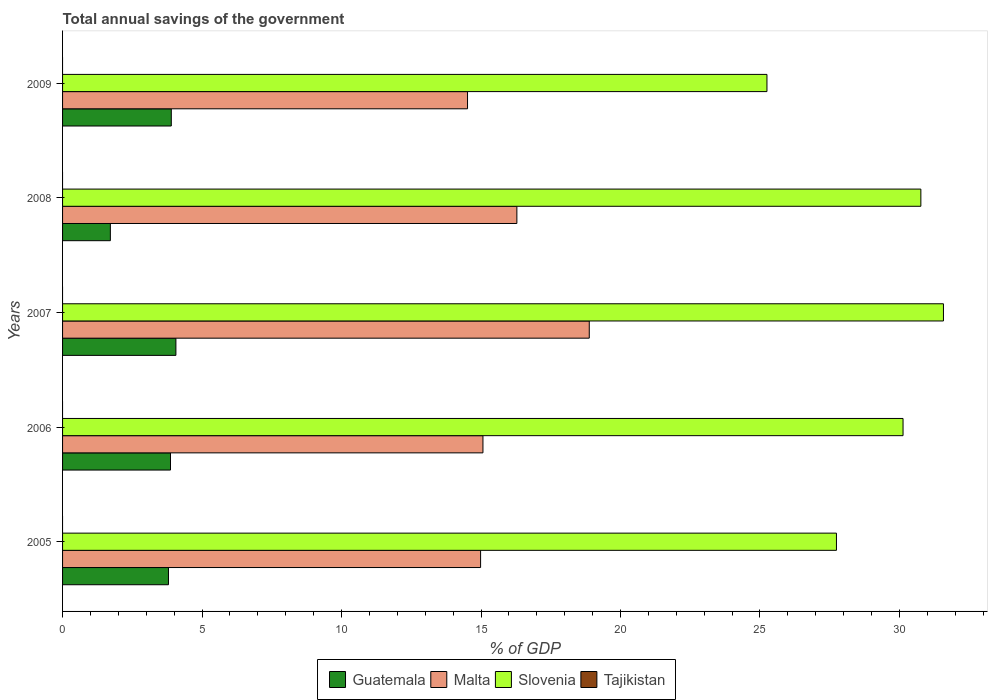How many groups of bars are there?
Give a very brief answer. 5. Are the number of bars on each tick of the Y-axis equal?
Ensure brevity in your answer.  Yes. In how many cases, is the number of bars for a given year not equal to the number of legend labels?
Make the answer very short. 5. Across all years, what is the maximum total annual savings of the government in Malta?
Your response must be concise. 18.88. Across all years, what is the minimum total annual savings of the government in Slovenia?
Make the answer very short. 25.25. What is the total total annual savings of the government in Guatemala in the graph?
Make the answer very short. 17.34. What is the difference between the total annual savings of the government in Guatemala in 2006 and that in 2008?
Give a very brief answer. 2.16. What is the difference between the total annual savings of the government in Malta in 2006 and the total annual savings of the government in Tajikistan in 2008?
Offer a very short reply. 15.07. What is the average total annual savings of the government in Guatemala per year?
Your answer should be very brief. 3.47. In the year 2007, what is the difference between the total annual savings of the government in Malta and total annual savings of the government in Guatemala?
Provide a succinct answer. 14.82. What is the ratio of the total annual savings of the government in Slovenia in 2007 to that in 2009?
Your answer should be compact. 1.25. Is the total annual savings of the government in Slovenia in 2007 less than that in 2008?
Ensure brevity in your answer.  No. Is the difference between the total annual savings of the government in Malta in 2008 and 2009 greater than the difference between the total annual savings of the government in Guatemala in 2008 and 2009?
Offer a terse response. Yes. What is the difference between the highest and the second highest total annual savings of the government in Malta?
Offer a terse response. 2.59. What is the difference between the highest and the lowest total annual savings of the government in Guatemala?
Give a very brief answer. 2.35. Is the sum of the total annual savings of the government in Malta in 2005 and 2006 greater than the maximum total annual savings of the government in Guatemala across all years?
Your answer should be very brief. Yes. Is it the case that in every year, the sum of the total annual savings of the government in Tajikistan and total annual savings of the government in Guatemala is greater than the sum of total annual savings of the government in Malta and total annual savings of the government in Slovenia?
Your answer should be compact. No. Are all the bars in the graph horizontal?
Your answer should be compact. Yes. What is the difference between two consecutive major ticks on the X-axis?
Your answer should be very brief. 5. What is the title of the graph?
Your answer should be compact. Total annual savings of the government. Does "Greece" appear as one of the legend labels in the graph?
Keep it short and to the point. No. What is the label or title of the X-axis?
Offer a terse response. % of GDP. What is the % of GDP of Guatemala in 2005?
Your answer should be compact. 3.8. What is the % of GDP of Malta in 2005?
Your answer should be very brief. 14.99. What is the % of GDP in Slovenia in 2005?
Provide a short and direct response. 27.74. What is the % of GDP in Tajikistan in 2005?
Your response must be concise. 0. What is the % of GDP of Guatemala in 2006?
Keep it short and to the point. 3.87. What is the % of GDP of Malta in 2006?
Your answer should be compact. 15.07. What is the % of GDP in Slovenia in 2006?
Provide a succinct answer. 30.13. What is the % of GDP of Tajikistan in 2006?
Your answer should be compact. 0. What is the % of GDP in Guatemala in 2007?
Provide a succinct answer. 4.06. What is the % of GDP in Malta in 2007?
Keep it short and to the point. 18.88. What is the % of GDP in Slovenia in 2007?
Your answer should be compact. 31.58. What is the % of GDP in Guatemala in 2008?
Your answer should be very brief. 1.71. What is the % of GDP in Malta in 2008?
Offer a very short reply. 16.29. What is the % of GDP in Slovenia in 2008?
Your answer should be very brief. 30.77. What is the % of GDP of Guatemala in 2009?
Make the answer very short. 3.9. What is the % of GDP of Malta in 2009?
Provide a short and direct response. 14.52. What is the % of GDP in Slovenia in 2009?
Make the answer very short. 25.25. What is the % of GDP in Tajikistan in 2009?
Your response must be concise. 0. Across all years, what is the maximum % of GDP in Guatemala?
Ensure brevity in your answer.  4.06. Across all years, what is the maximum % of GDP in Malta?
Offer a terse response. 18.88. Across all years, what is the maximum % of GDP in Slovenia?
Your answer should be compact. 31.58. Across all years, what is the minimum % of GDP of Guatemala?
Offer a very short reply. 1.71. Across all years, what is the minimum % of GDP of Malta?
Your response must be concise. 14.52. Across all years, what is the minimum % of GDP of Slovenia?
Provide a succinct answer. 25.25. What is the total % of GDP in Guatemala in the graph?
Your response must be concise. 17.34. What is the total % of GDP of Malta in the graph?
Your response must be concise. 79.74. What is the total % of GDP in Slovenia in the graph?
Offer a very short reply. 145.47. What is the difference between the % of GDP of Guatemala in 2005 and that in 2006?
Your answer should be compact. -0.07. What is the difference between the % of GDP of Malta in 2005 and that in 2006?
Keep it short and to the point. -0.08. What is the difference between the % of GDP in Slovenia in 2005 and that in 2006?
Keep it short and to the point. -2.39. What is the difference between the % of GDP of Guatemala in 2005 and that in 2007?
Your answer should be compact. -0.27. What is the difference between the % of GDP in Malta in 2005 and that in 2007?
Your answer should be compact. -3.9. What is the difference between the % of GDP of Slovenia in 2005 and that in 2007?
Provide a succinct answer. -3.84. What is the difference between the % of GDP of Guatemala in 2005 and that in 2008?
Your answer should be compact. 2.08. What is the difference between the % of GDP in Malta in 2005 and that in 2008?
Provide a succinct answer. -1.3. What is the difference between the % of GDP in Slovenia in 2005 and that in 2008?
Provide a succinct answer. -3.03. What is the difference between the % of GDP in Guatemala in 2005 and that in 2009?
Provide a short and direct response. -0.1. What is the difference between the % of GDP in Malta in 2005 and that in 2009?
Your response must be concise. 0.47. What is the difference between the % of GDP of Slovenia in 2005 and that in 2009?
Ensure brevity in your answer.  2.49. What is the difference between the % of GDP of Guatemala in 2006 and that in 2007?
Your response must be concise. -0.19. What is the difference between the % of GDP in Malta in 2006 and that in 2007?
Give a very brief answer. -3.81. What is the difference between the % of GDP in Slovenia in 2006 and that in 2007?
Make the answer very short. -1.45. What is the difference between the % of GDP of Guatemala in 2006 and that in 2008?
Your answer should be very brief. 2.16. What is the difference between the % of GDP in Malta in 2006 and that in 2008?
Make the answer very short. -1.22. What is the difference between the % of GDP in Slovenia in 2006 and that in 2008?
Your answer should be very brief. -0.64. What is the difference between the % of GDP in Guatemala in 2006 and that in 2009?
Your answer should be very brief. -0.03. What is the difference between the % of GDP of Malta in 2006 and that in 2009?
Provide a short and direct response. 0.55. What is the difference between the % of GDP in Slovenia in 2006 and that in 2009?
Keep it short and to the point. 4.88. What is the difference between the % of GDP of Guatemala in 2007 and that in 2008?
Give a very brief answer. 2.35. What is the difference between the % of GDP in Malta in 2007 and that in 2008?
Offer a very short reply. 2.59. What is the difference between the % of GDP of Slovenia in 2007 and that in 2008?
Ensure brevity in your answer.  0.81. What is the difference between the % of GDP in Guatemala in 2007 and that in 2009?
Your answer should be very brief. 0.17. What is the difference between the % of GDP in Malta in 2007 and that in 2009?
Offer a very short reply. 4.36. What is the difference between the % of GDP in Slovenia in 2007 and that in 2009?
Ensure brevity in your answer.  6.33. What is the difference between the % of GDP in Guatemala in 2008 and that in 2009?
Make the answer very short. -2.18. What is the difference between the % of GDP in Malta in 2008 and that in 2009?
Keep it short and to the point. 1.77. What is the difference between the % of GDP of Slovenia in 2008 and that in 2009?
Provide a succinct answer. 5.52. What is the difference between the % of GDP in Guatemala in 2005 and the % of GDP in Malta in 2006?
Make the answer very short. -11.27. What is the difference between the % of GDP in Guatemala in 2005 and the % of GDP in Slovenia in 2006?
Offer a very short reply. -26.33. What is the difference between the % of GDP in Malta in 2005 and the % of GDP in Slovenia in 2006?
Your answer should be compact. -15.14. What is the difference between the % of GDP in Guatemala in 2005 and the % of GDP in Malta in 2007?
Give a very brief answer. -15.08. What is the difference between the % of GDP in Guatemala in 2005 and the % of GDP in Slovenia in 2007?
Make the answer very short. -27.78. What is the difference between the % of GDP of Malta in 2005 and the % of GDP of Slovenia in 2007?
Provide a succinct answer. -16.59. What is the difference between the % of GDP of Guatemala in 2005 and the % of GDP of Malta in 2008?
Your answer should be compact. -12.49. What is the difference between the % of GDP in Guatemala in 2005 and the % of GDP in Slovenia in 2008?
Give a very brief answer. -26.97. What is the difference between the % of GDP of Malta in 2005 and the % of GDP of Slovenia in 2008?
Keep it short and to the point. -15.78. What is the difference between the % of GDP in Guatemala in 2005 and the % of GDP in Malta in 2009?
Keep it short and to the point. -10.72. What is the difference between the % of GDP in Guatemala in 2005 and the % of GDP in Slovenia in 2009?
Your answer should be very brief. -21.45. What is the difference between the % of GDP in Malta in 2005 and the % of GDP in Slovenia in 2009?
Keep it short and to the point. -10.27. What is the difference between the % of GDP in Guatemala in 2006 and the % of GDP in Malta in 2007?
Offer a terse response. -15.01. What is the difference between the % of GDP in Guatemala in 2006 and the % of GDP in Slovenia in 2007?
Your answer should be very brief. -27.71. What is the difference between the % of GDP of Malta in 2006 and the % of GDP of Slovenia in 2007?
Provide a short and direct response. -16.51. What is the difference between the % of GDP of Guatemala in 2006 and the % of GDP of Malta in 2008?
Your answer should be very brief. -12.42. What is the difference between the % of GDP of Guatemala in 2006 and the % of GDP of Slovenia in 2008?
Your answer should be very brief. -26.9. What is the difference between the % of GDP in Malta in 2006 and the % of GDP in Slovenia in 2008?
Ensure brevity in your answer.  -15.7. What is the difference between the % of GDP of Guatemala in 2006 and the % of GDP of Malta in 2009?
Make the answer very short. -10.65. What is the difference between the % of GDP in Guatemala in 2006 and the % of GDP in Slovenia in 2009?
Provide a short and direct response. -21.38. What is the difference between the % of GDP of Malta in 2006 and the % of GDP of Slovenia in 2009?
Your answer should be very brief. -10.18. What is the difference between the % of GDP of Guatemala in 2007 and the % of GDP of Malta in 2008?
Keep it short and to the point. -12.22. What is the difference between the % of GDP of Guatemala in 2007 and the % of GDP of Slovenia in 2008?
Provide a succinct answer. -26.7. What is the difference between the % of GDP in Malta in 2007 and the % of GDP in Slovenia in 2008?
Give a very brief answer. -11.89. What is the difference between the % of GDP of Guatemala in 2007 and the % of GDP of Malta in 2009?
Your answer should be compact. -10.45. What is the difference between the % of GDP of Guatemala in 2007 and the % of GDP of Slovenia in 2009?
Offer a terse response. -21.19. What is the difference between the % of GDP in Malta in 2007 and the % of GDP in Slovenia in 2009?
Keep it short and to the point. -6.37. What is the difference between the % of GDP in Guatemala in 2008 and the % of GDP in Malta in 2009?
Offer a very short reply. -12.8. What is the difference between the % of GDP of Guatemala in 2008 and the % of GDP of Slovenia in 2009?
Provide a short and direct response. -23.54. What is the difference between the % of GDP of Malta in 2008 and the % of GDP of Slovenia in 2009?
Ensure brevity in your answer.  -8.96. What is the average % of GDP in Guatemala per year?
Offer a very short reply. 3.47. What is the average % of GDP in Malta per year?
Your answer should be compact. 15.95. What is the average % of GDP in Slovenia per year?
Offer a terse response. 29.09. What is the average % of GDP in Tajikistan per year?
Your response must be concise. 0. In the year 2005, what is the difference between the % of GDP in Guatemala and % of GDP in Malta?
Offer a very short reply. -11.19. In the year 2005, what is the difference between the % of GDP of Guatemala and % of GDP of Slovenia?
Ensure brevity in your answer.  -23.95. In the year 2005, what is the difference between the % of GDP of Malta and % of GDP of Slovenia?
Your answer should be compact. -12.76. In the year 2006, what is the difference between the % of GDP in Guatemala and % of GDP in Malta?
Your response must be concise. -11.2. In the year 2006, what is the difference between the % of GDP of Guatemala and % of GDP of Slovenia?
Your response must be concise. -26.26. In the year 2006, what is the difference between the % of GDP of Malta and % of GDP of Slovenia?
Your answer should be compact. -15.06. In the year 2007, what is the difference between the % of GDP of Guatemala and % of GDP of Malta?
Provide a short and direct response. -14.82. In the year 2007, what is the difference between the % of GDP in Guatemala and % of GDP in Slovenia?
Provide a succinct answer. -27.52. In the year 2007, what is the difference between the % of GDP in Malta and % of GDP in Slovenia?
Offer a terse response. -12.7. In the year 2008, what is the difference between the % of GDP of Guatemala and % of GDP of Malta?
Your response must be concise. -14.57. In the year 2008, what is the difference between the % of GDP of Guatemala and % of GDP of Slovenia?
Your response must be concise. -29.05. In the year 2008, what is the difference between the % of GDP of Malta and % of GDP of Slovenia?
Provide a succinct answer. -14.48. In the year 2009, what is the difference between the % of GDP in Guatemala and % of GDP in Malta?
Offer a very short reply. -10.62. In the year 2009, what is the difference between the % of GDP of Guatemala and % of GDP of Slovenia?
Your answer should be compact. -21.35. In the year 2009, what is the difference between the % of GDP in Malta and % of GDP in Slovenia?
Provide a succinct answer. -10.73. What is the ratio of the % of GDP of Guatemala in 2005 to that in 2006?
Provide a short and direct response. 0.98. What is the ratio of the % of GDP of Malta in 2005 to that in 2006?
Provide a succinct answer. 0.99. What is the ratio of the % of GDP in Slovenia in 2005 to that in 2006?
Your answer should be very brief. 0.92. What is the ratio of the % of GDP of Guatemala in 2005 to that in 2007?
Offer a very short reply. 0.93. What is the ratio of the % of GDP of Malta in 2005 to that in 2007?
Give a very brief answer. 0.79. What is the ratio of the % of GDP in Slovenia in 2005 to that in 2007?
Your response must be concise. 0.88. What is the ratio of the % of GDP of Guatemala in 2005 to that in 2008?
Your answer should be compact. 2.22. What is the ratio of the % of GDP in Malta in 2005 to that in 2008?
Offer a very short reply. 0.92. What is the ratio of the % of GDP in Slovenia in 2005 to that in 2008?
Your answer should be very brief. 0.9. What is the ratio of the % of GDP in Malta in 2005 to that in 2009?
Your answer should be very brief. 1.03. What is the ratio of the % of GDP in Slovenia in 2005 to that in 2009?
Ensure brevity in your answer.  1.1. What is the ratio of the % of GDP of Guatemala in 2006 to that in 2007?
Give a very brief answer. 0.95. What is the ratio of the % of GDP in Malta in 2006 to that in 2007?
Offer a very short reply. 0.8. What is the ratio of the % of GDP of Slovenia in 2006 to that in 2007?
Give a very brief answer. 0.95. What is the ratio of the % of GDP of Guatemala in 2006 to that in 2008?
Make the answer very short. 2.26. What is the ratio of the % of GDP of Malta in 2006 to that in 2008?
Your response must be concise. 0.93. What is the ratio of the % of GDP of Slovenia in 2006 to that in 2008?
Make the answer very short. 0.98. What is the ratio of the % of GDP of Malta in 2006 to that in 2009?
Give a very brief answer. 1.04. What is the ratio of the % of GDP in Slovenia in 2006 to that in 2009?
Ensure brevity in your answer.  1.19. What is the ratio of the % of GDP of Guatemala in 2007 to that in 2008?
Ensure brevity in your answer.  2.37. What is the ratio of the % of GDP of Malta in 2007 to that in 2008?
Keep it short and to the point. 1.16. What is the ratio of the % of GDP of Slovenia in 2007 to that in 2008?
Ensure brevity in your answer.  1.03. What is the ratio of the % of GDP of Guatemala in 2007 to that in 2009?
Make the answer very short. 1.04. What is the ratio of the % of GDP of Malta in 2007 to that in 2009?
Your response must be concise. 1.3. What is the ratio of the % of GDP in Slovenia in 2007 to that in 2009?
Offer a terse response. 1.25. What is the ratio of the % of GDP in Guatemala in 2008 to that in 2009?
Keep it short and to the point. 0.44. What is the ratio of the % of GDP of Malta in 2008 to that in 2009?
Give a very brief answer. 1.12. What is the ratio of the % of GDP of Slovenia in 2008 to that in 2009?
Offer a terse response. 1.22. What is the difference between the highest and the second highest % of GDP of Guatemala?
Your answer should be compact. 0.17. What is the difference between the highest and the second highest % of GDP of Malta?
Offer a very short reply. 2.59. What is the difference between the highest and the second highest % of GDP of Slovenia?
Make the answer very short. 0.81. What is the difference between the highest and the lowest % of GDP in Guatemala?
Keep it short and to the point. 2.35. What is the difference between the highest and the lowest % of GDP of Malta?
Make the answer very short. 4.36. What is the difference between the highest and the lowest % of GDP in Slovenia?
Provide a succinct answer. 6.33. 